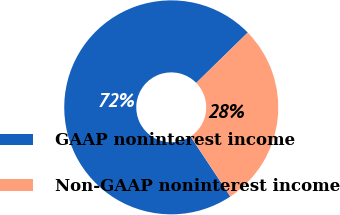<chart> <loc_0><loc_0><loc_500><loc_500><pie_chart><fcel>GAAP noninterest income<fcel>Non-GAAP noninterest income<nl><fcel>72.0%<fcel>28.0%<nl></chart> 